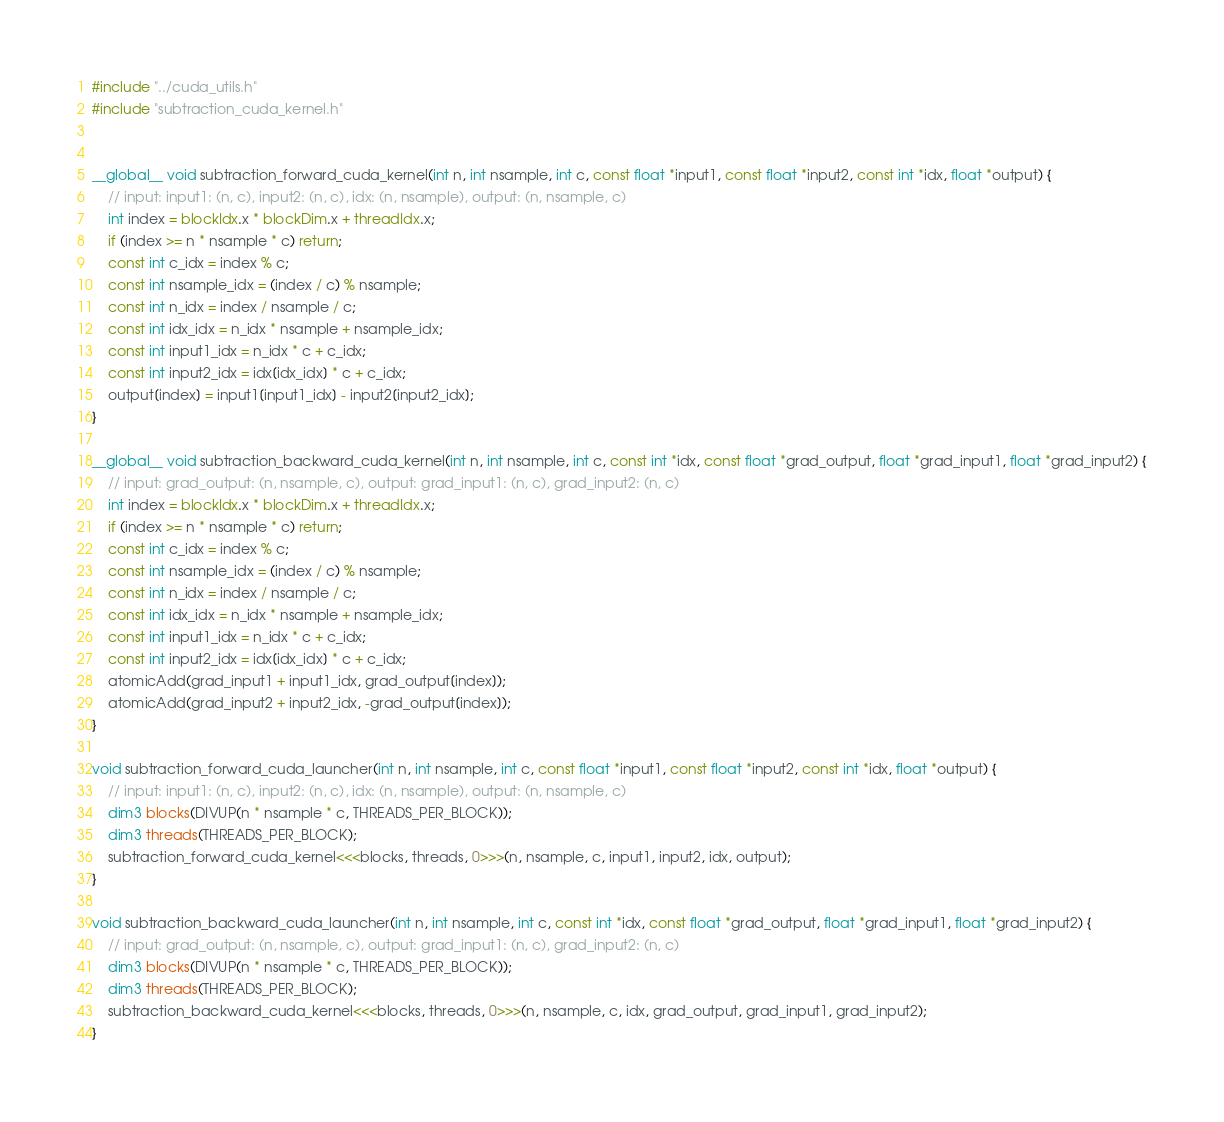<code> <loc_0><loc_0><loc_500><loc_500><_Cuda_>#include "../cuda_utils.h"
#include "subtraction_cuda_kernel.h"


__global__ void subtraction_forward_cuda_kernel(int n, int nsample, int c, const float *input1, const float *input2, const int *idx, float *output) {
    // input: input1: (n, c), input2: (n, c), idx: (n, nsample), output: (n, nsample, c)
    int index = blockIdx.x * blockDim.x + threadIdx.x;
    if (index >= n * nsample * c) return;
    const int c_idx = index % c;
    const int nsample_idx = (index / c) % nsample;
    const int n_idx = index / nsample / c;
    const int idx_idx = n_idx * nsample + nsample_idx;
    const int input1_idx = n_idx * c + c_idx;
    const int input2_idx = idx[idx_idx] * c + c_idx;
    output[index] = input1[input1_idx] - input2[input2_idx];
}

__global__ void subtraction_backward_cuda_kernel(int n, int nsample, int c, const int *idx, const float *grad_output, float *grad_input1, float *grad_input2) {
    // input: grad_output: (n, nsample, c), output: grad_input1: (n, c), grad_input2: (n, c)
    int index = blockIdx.x * blockDim.x + threadIdx.x;
    if (index >= n * nsample * c) return;
    const int c_idx = index % c;
    const int nsample_idx = (index / c) % nsample;
    const int n_idx = index / nsample / c;
    const int idx_idx = n_idx * nsample + nsample_idx;
    const int input1_idx = n_idx * c + c_idx;
    const int input2_idx = idx[idx_idx] * c + c_idx;
    atomicAdd(grad_input1 + input1_idx, grad_output[index]);
    atomicAdd(grad_input2 + input2_idx, -grad_output[index]);
}

void subtraction_forward_cuda_launcher(int n, int nsample, int c, const float *input1, const float *input2, const int *idx, float *output) {
    // input: input1: (n, c), input2: (n, c), idx: (n, nsample), output: (n, nsample, c)
    dim3 blocks(DIVUP(n * nsample * c, THREADS_PER_BLOCK));
    dim3 threads(THREADS_PER_BLOCK);
    subtraction_forward_cuda_kernel<<<blocks, threads, 0>>>(n, nsample, c, input1, input2, idx, output);
}

void subtraction_backward_cuda_launcher(int n, int nsample, int c, const int *idx, const float *grad_output, float *grad_input1, float *grad_input2) {  
    // input: grad_output: (n, nsample, c), output: grad_input1: (n, c), grad_input2: (n, c)
    dim3 blocks(DIVUP(n * nsample * c, THREADS_PER_BLOCK));
    dim3 threads(THREADS_PER_BLOCK);
    subtraction_backward_cuda_kernel<<<blocks, threads, 0>>>(n, nsample, c, idx, grad_output, grad_input1, grad_input2);
}
</code> 